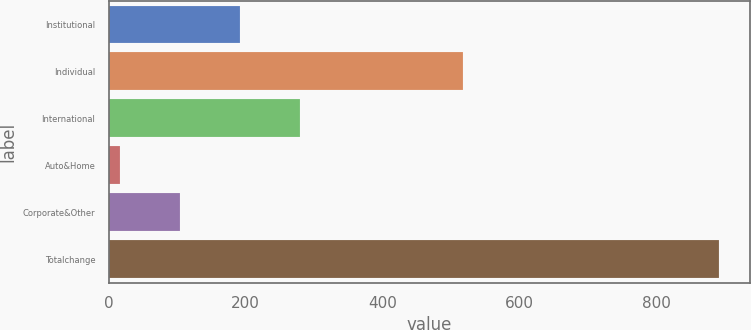Convert chart to OTSL. <chart><loc_0><loc_0><loc_500><loc_500><bar_chart><fcel>Institutional<fcel>Individual<fcel>International<fcel>Auto&Home<fcel>Corporate&Other<fcel>Totalchange<nl><fcel>192<fcel>518<fcel>279.5<fcel>17<fcel>104.5<fcel>892<nl></chart> 